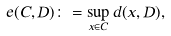<formula> <loc_0><loc_0><loc_500><loc_500>e ( C , D ) \colon = \sup _ { x \in C } d ( x , D ) ,</formula> 